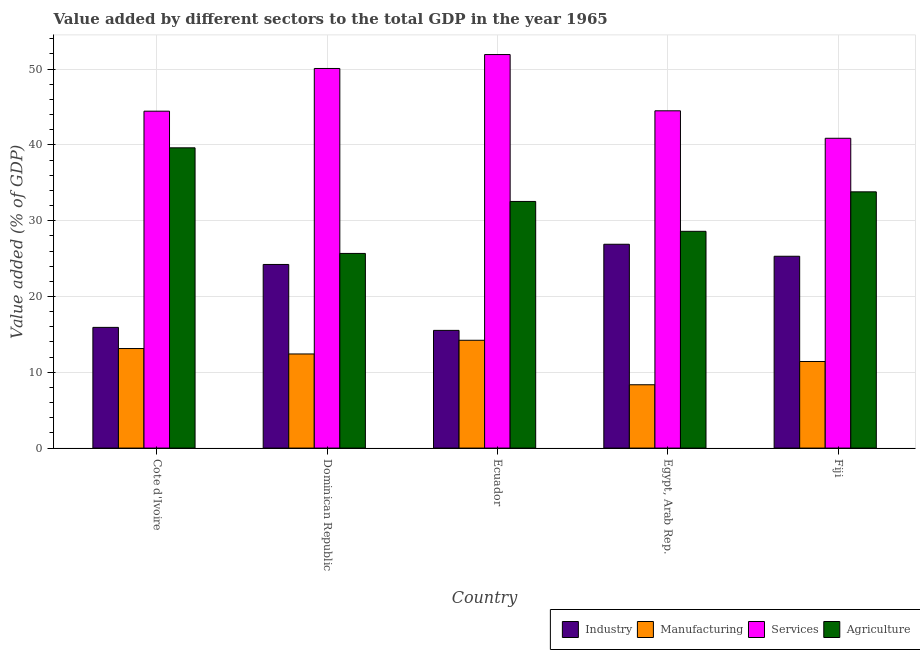How many different coloured bars are there?
Offer a terse response. 4. How many groups of bars are there?
Provide a succinct answer. 5. What is the label of the 4th group of bars from the left?
Your answer should be compact. Egypt, Arab Rep. What is the value added by industrial sector in Egypt, Arab Rep.?
Provide a succinct answer. 26.9. Across all countries, what is the maximum value added by manufacturing sector?
Offer a very short reply. 14.23. Across all countries, what is the minimum value added by agricultural sector?
Offer a terse response. 25.68. In which country was the value added by industrial sector maximum?
Offer a terse response. Egypt, Arab Rep. In which country was the value added by agricultural sector minimum?
Keep it short and to the point. Dominican Republic. What is the total value added by services sector in the graph?
Offer a very short reply. 231.85. What is the difference between the value added by services sector in Ecuador and that in Egypt, Arab Rep.?
Give a very brief answer. 7.42. What is the difference between the value added by industrial sector in Dominican Republic and the value added by agricultural sector in Egypt, Arab Rep.?
Offer a very short reply. -4.37. What is the average value added by manufacturing sector per country?
Keep it short and to the point. 11.91. What is the difference between the value added by manufacturing sector and value added by industrial sector in Egypt, Arab Rep.?
Make the answer very short. -18.54. In how many countries, is the value added by agricultural sector greater than 26 %?
Keep it short and to the point. 4. What is the ratio of the value added by industrial sector in Ecuador to that in Egypt, Arab Rep.?
Provide a succinct answer. 0.58. What is the difference between the highest and the second highest value added by industrial sector?
Provide a short and direct response. 1.58. What is the difference between the highest and the lowest value added by manufacturing sector?
Offer a terse response. 5.87. Is the sum of the value added by industrial sector in Egypt, Arab Rep. and Fiji greater than the maximum value added by agricultural sector across all countries?
Your response must be concise. Yes. What does the 4th bar from the left in Cote d'Ivoire represents?
Your answer should be compact. Agriculture. What does the 1st bar from the right in Cote d'Ivoire represents?
Offer a terse response. Agriculture. Is it the case that in every country, the sum of the value added by industrial sector and value added by manufacturing sector is greater than the value added by services sector?
Ensure brevity in your answer.  No. Are all the bars in the graph horizontal?
Your response must be concise. No. How many countries are there in the graph?
Keep it short and to the point. 5. Are the values on the major ticks of Y-axis written in scientific E-notation?
Make the answer very short. No. Does the graph contain any zero values?
Your answer should be compact. No. Where does the legend appear in the graph?
Your response must be concise. Bottom right. What is the title of the graph?
Your answer should be very brief. Value added by different sectors to the total GDP in the year 1965. What is the label or title of the X-axis?
Ensure brevity in your answer.  Country. What is the label or title of the Y-axis?
Offer a very short reply. Value added (% of GDP). What is the Value added (% of GDP) of Industry in Cote d'Ivoire?
Offer a very short reply. 15.93. What is the Value added (% of GDP) in Manufacturing in Cote d'Ivoire?
Offer a very short reply. 13.13. What is the Value added (% of GDP) in Services in Cote d'Ivoire?
Give a very brief answer. 44.45. What is the Value added (% of GDP) in Agriculture in Cote d'Ivoire?
Your answer should be compact. 39.62. What is the Value added (% of GDP) of Industry in Dominican Republic?
Offer a terse response. 24.23. What is the Value added (% of GDP) of Manufacturing in Dominican Republic?
Your response must be concise. 12.42. What is the Value added (% of GDP) in Services in Dominican Republic?
Offer a very short reply. 50.09. What is the Value added (% of GDP) of Agriculture in Dominican Republic?
Offer a very short reply. 25.68. What is the Value added (% of GDP) in Industry in Ecuador?
Give a very brief answer. 15.53. What is the Value added (% of GDP) in Manufacturing in Ecuador?
Give a very brief answer. 14.23. What is the Value added (% of GDP) in Services in Ecuador?
Offer a very short reply. 51.93. What is the Value added (% of GDP) of Agriculture in Ecuador?
Give a very brief answer. 32.54. What is the Value added (% of GDP) of Industry in Egypt, Arab Rep.?
Your response must be concise. 26.9. What is the Value added (% of GDP) of Manufacturing in Egypt, Arab Rep.?
Give a very brief answer. 8.36. What is the Value added (% of GDP) in Services in Egypt, Arab Rep.?
Ensure brevity in your answer.  44.5. What is the Value added (% of GDP) of Agriculture in Egypt, Arab Rep.?
Offer a very short reply. 28.6. What is the Value added (% of GDP) of Industry in Fiji?
Provide a succinct answer. 25.31. What is the Value added (% of GDP) in Manufacturing in Fiji?
Your answer should be very brief. 11.43. What is the Value added (% of GDP) of Services in Fiji?
Ensure brevity in your answer.  40.88. What is the Value added (% of GDP) of Agriculture in Fiji?
Your response must be concise. 33.81. Across all countries, what is the maximum Value added (% of GDP) of Industry?
Make the answer very short. 26.9. Across all countries, what is the maximum Value added (% of GDP) in Manufacturing?
Ensure brevity in your answer.  14.23. Across all countries, what is the maximum Value added (% of GDP) in Services?
Offer a terse response. 51.93. Across all countries, what is the maximum Value added (% of GDP) of Agriculture?
Your response must be concise. 39.62. Across all countries, what is the minimum Value added (% of GDP) in Industry?
Offer a terse response. 15.53. Across all countries, what is the minimum Value added (% of GDP) in Manufacturing?
Provide a short and direct response. 8.36. Across all countries, what is the minimum Value added (% of GDP) of Services?
Keep it short and to the point. 40.88. Across all countries, what is the minimum Value added (% of GDP) in Agriculture?
Keep it short and to the point. 25.68. What is the total Value added (% of GDP) in Industry in the graph?
Provide a succinct answer. 107.89. What is the total Value added (% of GDP) of Manufacturing in the graph?
Make the answer very short. 59.56. What is the total Value added (% of GDP) of Services in the graph?
Your answer should be compact. 231.85. What is the total Value added (% of GDP) of Agriculture in the graph?
Keep it short and to the point. 160.26. What is the difference between the Value added (% of GDP) in Industry in Cote d'Ivoire and that in Dominican Republic?
Offer a very short reply. -8.3. What is the difference between the Value added (% of GDP) of Manufacturing in Cote d'Ivoire and that in Dominican Republic?
Ensure brevity in your answer.  0.72. What is the difference between the Value added (% of GDP) in Services in Cote d'Ivoire and that in Dominican Republic?
Give a very brief answer. -5.63. What is the difference between the Value added (% of GDP) of Agriculture in Cote d'Ivoire and that in Dominican Republic?
Your answer should be compact. 13.93. What is the difference between the Value added (% of GDP) in Industry in Cote d'Ivoire and that in Ecuador?
Keep it short and to the point. 0.4. What is the difference between the Value added (% of GDP) of Manufacturing in Cote d'Ivoire and that in Ecuador?
Ensure brevity in your answer.  -1.09. What is the difference between the Value added (% of GDP) of Services in Cote d'Ivoire and that in Ecuador?
Your response must be concise. -7.47. What is the difference between the Value added (% of GDP) in Agriculture in Cote d'Ivoire and that in Ecuador?
Provide a succinct answer. 7.08. What is the difference between the Value added (% of GDP) of Industry in Cote d'Ivoire and that in Egypt, Arab Rep.?
Keep it short and to the point. -10.97. What is the difference between the Value added (% of GDP) of Manufacturing in Cote d'Ivoire and that in Egypt, Arab Rep.?
Provide a short and direct response. 4.78. What is the difference between the Value added (% of GDP) of Services in Cote d'Ivoire and that in Egypt, Arab Rep.?
Give a very brief answer. -0.05. What is the difference between the Value added (% of GDP) in Agriculture in Cote d'Ivoire and that in Egypt, Arab Rep.?
Provide a succinct answer. 11.02. What is the difference between the Value added (% of GDP) in Industry in Cote d'Ivoire and that in Fiji?
Keep it short and to the point. -9.38. What is the difference between the Value added (% of GDP) in Manufacturing in Cote d'Ivoire and that in Fiji?
Offer a terse response. 1.71. What is the difference between the Value added (% of GDP) of Services in Cote d'Ivoire and that in Fiji?
Offer a very short reply. 3.58. What is the difference between the Value added (% of GDP) in Agriculture in Cote d'Ivoire and that in Fiji?
Your response must be concise. 5.81. What is the difference between the Value added (% of GDP) of Industry in Dominican Republic and that in Ecuador?
Ensure brevity in your answer.  8.7. What is the difference between the Value added (% of GDP) in Manufacturing in Dominican Republic and that in Ecuador?
Make the answer very short. -1.81. What is the difference between the Value added (% of GDP) of Services in Dominican Republic and that in Ecuador?
Keep it short and to the point. -1.84. What is the difference between the Value added (% of GDP) in Agriculture in Dominican Republic and that in Ecuador?
Keep it short and to the point. -6.86. What is the difference between the Value added (% of GDP) of Industry in Dominican Republic and that in Egypt, Arab Rep.?
Your response must be concise. -2.67. What is the difference between the Value added (% of GDP) of Manufacturing in Dominican Republic and that in Egypt, Arab Rep.?
Provide a succinct answer. 4.06. What is the difference between the Value added (% of GDP) of Services in Dominican Republic and that in Egypt, Arab Rep.?
Make the answer very short. 5.58. What is the difference between the Value added (% of GDP) of Agriculture in Dominican Republic and that in Egypt, Arab Rep.?
Keep it short and to the point. -2.92. What is the difference between the Value added (% of GDP) of Industry in Dominican Republic and that in Fiji?
Offer a very short reply. -1.08. What is the difference between the Value added (% of GDP) in Services in Dominican Republic and that in Fiji?
Provide a succinct answer. 9.21. What is the difference between the Value added (% of GDP) of Agriculture in Dominican Republic and that in Fiji?
Offer a very short reply. -8.13. What is the difference between the Value added (% of GDP) of Industry in Ecuador and that in Egypt, Arab Rep.?
Provide a short and direct response. -11.36. What is the difference between the Value added (% of GDP) in Manufacturing in Ecuador and that in Egypt, Arab Rep.?
Provide a short and direct response. 5.87. What is the difference between the Value added (% of GDP) of Services in Ecuador and that in Egypt, Arab Rep.?
Provide a succinct answer. 7.42. What is the difference between the Value added (% of GDP) in Agriculture in Ecuador and that in Egypt, Arab Rep.?
Your answer should be compact. 3.94. What is the difference between the Value added (% of GDP) in Industry in Ecuador and that in Fiji?
Keep it short and to the point. -9.78. What is the difference between the Value added (% of GDP) in Manufacturing in Ecuador and that in Fiji?
Offer a terse response. 2.8. What is the difference between the Value added (% of GDP) of Services in Ecuador and that in Fiji?
Your answer should be compact. 11.05. What is the difference between the Value added (% of GDP) in Agriculture in Ecuador and that in Fiji?
Offer a very short reply. -1.27. What is the difference between the Value added (% of GDP) in Industry in Egypt, Arab Rep. and that in Fiji?
Your answer should be compact. 1.58. What is the difference between the Value added (% of GDP) of Manufacturing in Egypt, Arab Rep. and that in Fiji?
Provide a short and direct response. -3.07. What is the difference between the Value added (% of GDP) in Services in Egypt, Arab Rep. and that in Fiji?
Your answer should be compact. 3.62. What is the difference between the Value added (% of GDP) of Agriculture in Egypt, Arab Rep. and that in Fiji?
Ensure brevity in your answer.  -5.21. What is the difference between the Value added (% of GDP) in Industry in Cote d'Ivoire and the Value added (% of GDP) in Manufacturing in Dominican Republic?
Give a very brief answer. 3.51. What is the difference between the Value added (% of GDP) of Industry in Cote d'Ivoire and the Value added (% of GDP) of Services in Dominican Republic?
Offer a terse response. -34.16. What is the difference between the Value added (% of GDP) of Industry in Cote d'Ivoire and the Value added (% of GDP) of Agriculture in Dominican Republic?
Give a very brief answer. -9.76. What is the difference between the Value added (% of GDP) of Manufacturing in Cote d'Ivoire and the Value added (% of GDP) of Services in Dominican Republic?
Give a very brief answer. -36.95. What is the difference between the Value added (% of GDP) in Manufacturing in Cote d'Ivoire and the Value added (% of GDP) in Agriculture in Dominican Republic?
Offer a very short reply. -12.55. What is the difference between the Value added (% of GDP) in Services in Cote d'Ivoire and the Value added (% of GDP) in Agriculture in Dominican Republic?
Your response must be concise. 18.77. What is the difference between the Value added (% of GDP) in Industry in Cote d'Ivoire and the Value added (% of GDP) in Manufacturing in Ecuador?
Provide a succinct answer. 1.7. What is the difference between the Value added (% of GDP) of Industry in Cote d'Ivoire and the Value added (% of GDP) of Services in Ecuador?
Give a very brief answer. -36. What is the difference between the Value added (% of GDP) of Industry in Cote d'Ivoire and the Value added (% of GDP) of Agriculture in Ecuador?
Offer a terse response. -16.62. What is the difference between the Value added (% of GDP) in Manufacturing in Cote d'Ivoire and the Value added (% of GDP) in Services in Ecuador?
Your answer should be compact. -38.79. What is the difference between the Value added (% of GDP) in Manufacturing in Cote d'Ivoire and the Value added (% of GDP) in Agriculture in Ecuador?
Provide a succinct answer. -19.41. What is the difference between the Value added (% of GDP) of Services in Cote d'Ivoire and the Value added (% of GDP) of Agriculture in Ecuador?
Provide a succinct answer. 11.91. What is the difference between the Value added (% of GDP) of Industry in Cote d'Ivoire and the Value added (% of GDP) of Manufacturing in Egypt, Arab Rep.?
Offer a very short reply. 7.57. What is the difference between the Value added (% of GDP) in Industry in Cote d'Ivoire and the Value added (% of GDP) in Services in Egypt, Arab Rep.?
Give a very brief answer. -28.58. What is the difference between the Value added (% of GDP) in Industry in Cote d'Ivoire and the Value added (% of GDP) in Agriculture in Egypt, Arab Rep.?
Keep it short and to the point. -12.67. What is the difference between the Value added (% of GDP) of Manufacturing in Cote d'Ivoire and the Value added (% of GDP) of Services in Egypt, Arab Rep.?
Ensure brevity in your answer.  -31.37. What is the difference between the Value added (% of GDP) in Manufacturing in Cote d'Ivoire and the Value added (% of GDP) in Agriculture in Egypt, Arab Rep.?
Offer a terse response. -15.47. What is the difference between the Value added (% of GDP) in Services in Cote d'Ivoire and the Value added (% of GDP) in Agriculture in Egypt, Arab Rep.?
Ensure brevity in your answer.  15.85. What is the difference between the Value added (% of GDP) of Industry in Cote d'Ivoire and the Value added (% of GDP) of Manufacturing in Fiji?
Provide a short and direct response. 4.5. What is the difference between the Value added (% of GDP) in Industry in Cote d'Ivoire and the Value added (% of GDP) in Services in Fiji?
Offer a terse response. -24.95. What is the difference between the Value added (% of GDP) in Industry in Cote d'Ivoire and the Value added (% of GDP) in Agriculture in Fiji?
Give a very brief answer. -17.88. What is the difference between the Value added (% of GDP) in Manufacturing in Cote d'Ivoire and the Value added (% of GDP) in Services in Fiji?
Your answer should be very brief. -27.74. What is the difference between the Value added (% of GDP) of Manufacturing in Cote d'Ivoire and the Value added (% of GDP) of Agriculture in Fiji?
Make the answer very short. -20.68. What is the difference between the Value added (% of GDP) of Services in Cote d'Ivoire and the Value added (% of GDP) of Agriculture in Fiji?
Provide a short and direct response. 10.64. What is the difference between the Value added (% of GDP) in Industry in Dominican Republic and the Value added (% of GDP) in Manufacturing in Ecuador?
Offer a very short reply. 10. What is the difference between the Value added (% of GDP) of Industry in Dominican Republic and the Value added (% of GDP) of Services in Ecuador?
Keep it short and to the point. -27.7. What is the difference between the Value added (% of GDP) in Industry in Dominican Republic and the Value added (% of GDP) in Agriculture in Ecuador?
Provide a succinct answer. -8.31. What is the difference between the Value added (% of GDP) in Manufacturing in Dominican Republic and the Value added (% of GDP) in Services in Ecuador?
Provide a short and direct response. -39.51. What is the difference between the Value added (% of GDP) in Manufacturing in Dominican Republic and the Value added (% of GDP) in Agriculture in Ecuador?
Make the answer very short. -20.12. What is the difference between the Value added (% of GDP) of Services in Dominican Republic and the Value added (% of GDP) of Agriculture in Ecuador?
Your answer should be compact. 17.54. What is the difference between the Value added (% of GDP) of Industry in Dominican Republic and the Value added (% of GDP) of Manufacturing in Egypt, Arab Rep.?
Your answer should be very brief. 15.87. What is the difference between the Value added (% of GDP) in Industry in Dominican Republic and the Value added (% of GDP) in Services in Egypt, Arab Rep.?
Your answer should be very brief. -20.28. What is the difference between the Value added (% of GDP) of Industry in Dominican Republic and the Value added (% of GDP) of Agriculture in Egypt, Arab Rep.?
Keep it short and to the point. -4.37. What is the difference between the Value added (% of GDP) in Manufacturing in Dominican Republic and the Value added (% of GDP) in Services in Egypt, Arab Rep.?
Your response must be concise. -32.08. What is the difference between the Value added (% of GDP) of Manufacturing in Dominican Republic and the Value added (% of GDP) of Agriculture in Egypt, Arab Rep.?
Ensure brevity in your answer.  -16.18. What is the difference between the Value added (% of GDP) of Services in Dominican Republic and the Value added (% of GDP) of Agriculture in Egypt, Arab Rep.?
Your answer should be very brief. 21.49. What is the difference between the Value added (% of GDP) of Industry in Dominican Republic and the Value added (% of GDP) of Manufacturing in Fiji?
Keep it short and to the point. 12.8. What is the difference between the Value added (% of GDP) of Industry in Dominican Republic and the Value added (% of GDP) of Services in Fiji?
Offer a terse response. -16.65. What is the difference between the Value added (% of GDP) of Industry in Dominican Republic and the Value added (% of GDP) of Agriculture in Fiji?
Offer a very short reply. -9.58. What is the difference between the Value added (% of GDP) in Manufacturing in Dominican Republic and the Value added (% of GDP) in Services in Fiji?
Ensure brevity in your answer.  -28.46. What is the difference between the Value added (% of GDP) in Manufacturing in Dominican Republic and the Value added (% of GDP) in Agriculture in Fiji?
Your answer should be very brief. -21.39. What is the difference between the Value added (% of GDP) in Services in Dominican Republic and the Value added (% of GDP) in Agriculture in Fiji?
Offer a terse response. 16.28. What is the difference between the Value added (% of GDP) of Industry in Ecuador and the Value added (% of GDP) of Manufacturing in Egypt, Arab Rep.?
Give a very brief answer. 7.17. What is the difference between the Value added (% of GDP) of Industry in Ecuador and the Value added (% of GDP) of Services in Egypt, Arab Rep.?
Offer a terse response. -28.97. What is the difference between the Value added (% of GDP) of Industry in Ecuador and the Value added (% of GDP) of Agriculture in Egypt, Arab Rep.?
Offer a very short reply. -13.07. What is the difference between the Value added (% of GDP) of Manufacturing in Ecuador and the Value added (% of GDP) of Services in Egypt, Arab Rep.?
Make the answer very short. -30.28. What is the difference between the Value added (% of GDP) of Manufacturing in Ecuador and the Value added (% of GDP) of Agriculture in Egypt, Arab Rep.?
Give a very brief answer. -14.38. What is the difference between the Value added (% of GDP) of Services in Ecuador and the Value added (% of GDP) of Agriculture in Egypt, Arab Rep.?
Make the answer very short. 23.32. What is the difference between the Value added (% of GDP) of Industry in Ecuador and the Value added (% of GDP) of Manufacturing in Fiji?
Give a very brief answer. 4.11. What is the difference between the Value added (% of GDP) in Industry in Ecuador and the Value added (% of GDP) in Services in Fiji?
Give a very brief answer. -25.35. What is the difference between the Value added (% of GDP) of Industry in Ecuador and the Value added (% of GDP) of Agriculture in Fiji?
Make the answer very short. -18.28. What is the difference between the Value added (% of GDP) in Manufacturing in Ecuador and the Value added (% of GDP) in Services in Fiji?
Your answer should be compact. -26.65. What is the difference between the Value added (% of GDP) of Manufacturing in Ecuador and the Value added (% of GDP) of Agriculture in Fiji?
Provide a succinct answer. -19.59. What is the difference between the Value added (% of GDP) in Services in Ecuador and the Value added (% of GDP) in Agriculture in Fiji?
Your answer should be compact. 18.11. What is the difference between the Value added (% of GDP) of Industry in Egypt, Arab Rep. and the Value added (% of GDP) of Manufacturing in Fiji?
Offer a terse response. 15.47. What is the difference between the Value added (% of GDP) of Industry in Egypt, Arab Rep. and the Value added (% of GDP) of Services in Fiji?
Offer a very short reply. -13.98. What is the difference between the Value added (% of GDP) of Industry in Egypt, Arab Rep. and the Value added (% of GDP) of Agriculture in Fiji?
Ensure brevity in your answer.  -6.92. What is the difference between the Value added (% of GDP) in Manufacturing in Egypt, Arab Rep. and the Value added (% of GDP) in Services in Fiji?
Offer a terse response. -32.52. What is the difference between the Value added (% of GDP) in Manufacturing in Egypt, Arab Rep. and the Value added (% of GDP) in Agriculture in Fiji?
Offer a terse response. -25.45. What is the difference between the Value added (% of GDP) in Services in Egypt, Arab Rep. and the Value added (% of GDP) in Agriculture in Fiji?
Your response must be concise. 10.69. What is the average Value added (% of GDP) in Industry per country?
Provide a short and direct response. 21.58. What is the average Value added (% of GDP) of Manufacturing per country?
Your response must be concise. 11.91. What is the average Value added (% of GDP) in Services per country?
Your answer should be very brief. 46.37. What is the average Value added (% of GDP) of Agriculture per country?
Make the answer very short. 32.05. What is the difference between the Value added (% of GDP) in Industry and Value added (% of GDP) in Manufacturing in Cote d'Ivoire?
Offer a terse response. 2.79. What is the difference between the Value added (% of GDP) in Industry and Value added (% of GDP) in Services in Cote d'Ivoire?
Your answer should be compact. -28.53. What is the difference between the Value added (% of GDP) in Industry and Value added (% of GDP) in Agriculture in Cote d'Ivoire?
Your response must be concise. -23.69. What is the difference between the Value added (% of GDP) in Manufacturing and Value added (% of GDP) in Services in Cote d'Ivoire?
Keep it short and to the point. -31.32. What is the difference between the Value added (% of GDP) in Manufacturing and Value added (% of GDP) in Agriculture in Cote d'Ivoire?
Your answer should be very brief. -26.48. What is the difference between the Value added (% of GDP) in Services and Value added (% of GDP) in Agriculture in Cote d'Ivoire?
Offer a very short reply. 4.84. What is the difference between the Value added (% of GDP) of Industry and Value added (% of GDP) of Manufacturing in Dominican Republic?
Offer a terse response. 11.81. What is the difference between the Value added (% of GDP) in Industry and Value added (% of GDP) in Services in Dominican Republic?
Your answer should be very brief. -25.86. What is the difference between the Value added (% of GDP) of Industry and Value added (% of GDP) of Agriculture in Dominican Republic?
Make the answer very short. -1.46. What is the difference between the Value added (% of GDP) in Manufacturing and Value added (% of GDP) in Services in Dominican Republic?
Give a very brief answer. -37.67. What is the difference between the Value added (% of GDP) of Manufacturing and Value added (% of GDP) of Agriculture in Dominican Republic?
Give a very brief answer. -13.27. What is the difference between the Value added (% of GDP) of Services and Value added (% of GDP) of Agriculture in Dominican Republic?
Your answer should be very brief. 24.4. What is the difference between the Value added (% of GDP) in Industry and Value added (% of GDP) in Manufacturing in Ecuador?
Make the answer very short. 1.31. What is the difference between the Value added (% of GDP) in Industry and Value added (% of GDP) in Services in Ecuador?
Your response must be concise. -36.39. What is the difference between the Value added (% of GDP) in Industry and Value added (% of GDP) in Agriculture in Ecuador?
Give a very brief answer. -17.01. What is the difference between the Value added (% of GDP) in Manufacturing and Value added (% of GDP) in Services in Ecuador?
Ensure brevity in your answer.  -37.7. What is the difference between the Value added (% of GDP) in Manufacturing and Value added (% of GDP) in Agriculture in Ecuador?
Keep it short and to the point. -18.32. What is the difference between the Value added (% of GDP) in Services and Value added (% of GDP) in Agriculture in Ecuador?
Give a very brief answer. 19.38. What is the difference between the Value added (% of GDP) in Industry and Value added (% of GDP) in Manufacturing in Egypt, Arab Rep.?
Provide a succinct answer. 18.54. What is the difference between the Value added (% of GDP) of Industry and Value added (% of GDP) of Services in Egypt, Arab Rep.?
Provide a succinct answer. -17.61. What is the difference between the Value added (% of GDP) in Industry and Value added (% of GDP) in Agriculture in Egypt, Arab Rep.?
Ensure brevity in your answer.  -1.71. What is the difference between the Value added (% of GDP) in Manufacturing and Value added (% of GDP) in Services in Egypt, Arab Rep.?
Your answer should be compact. -36.15. What is the difference between the Value added (% of GDP) in Manufacturing and Value added (% of GDP) in Agriculture in Egypt, Arab Rep.?
Provide a short and direct response. -20.24. What is the difference between the Value added (% of GDP) of Services and Value added (% of GDP) of Agriculture in Egypt, Arab Rep.?
Make the answer very short. 15.9. What is the difference between the Value added (% of GDP) of Industry and Value added (% of GDP) of Manufacturing in Fiji?
Make the answer very short. 13.88. What is the difference between the Value added (% of GDP) in Industry and Value added (% of GDP) in Services in Fiji?
Provide a short and direct response. -15.57. What is the difference between the Value added (% of GDP) in Industry and Value added (% of GDP) in Agriculture in Fiji?
Keep it short and to the point. -8.5. What is the difference between the Value added (% of GDP) in Manufacturing and Value added (% of GDP) in Services in Fiji?
Give a very brief answer. -29.45. What is the difference between the Value added (% of GDP) of Manufacturing and Value added (% of GDP) of Agriculture in Fiji?
Provide a short and direct response. -22.38. What is the difference between the Value added (% of GDP) of Services and Value added (% of GDP) of Agriculture in Fiji?
Your response must be concise. 7.07. What is the ratio of the Value added (% of GDP) of Industry in Cote d'Ivoire to that in Dominican Republic?
Provide a short and direct response. 0.66. What is the ratio of the Value added (% of GDP) in Manufacturing in Cote d'Ivoire to that in Dominican Republic?
Provide a succinct answer. 1.06. What is the ratio of the Value added (% of GDP) in Services in Cote d'Ivoire to that in Dominican Republic?
Ensure brevity in your answer.  0.89. What is the ratio of the Value added (% of GDP) of Agriculture in Cote d'Ivoire to that in Dominican Republic?
Offer a very short reply. 1.54. What is the ratio of the Value added (% of GDP) in Industry in Cote d'Ivoire to that in Ecuador?
Ensure brevity in your answer.  1.03. What is the ratio of the Value added (% of GDP) in Manufacturing in Cote d'Ivoire to that in Ecuador?
Offer a very short reply. 0.92. What is the ratio of the Value added (% of GDP) in Services in Cote d'Ivoire to that in Ecuador?
Your answer should be compact. 0.86. What is the ratio of the Value added (% of GDP) in Agriculture in Cote d'Ivoire to that in Ecuador?
Give a very brief answer. 1.22. What is the ratio of the Value added (% of GDP) of Industry in Cote d'Ivoire to that in Egypt, Arab Rep.?
Provide a succinct answer. 0.59. What is the ratio of the Value added (% of GDP) of Manufacturing in Cote d'Ivoire to that in Egypt, Arab Rep.?
Make the answer very short. 1.57. What is the ratio of the Value added (% of GDP) of Services in Cote d'Ivoire to that in Egypt, Arab Rep.?
Provide a short and direct response. 1. What is the ratio of the Value added (% of GDP) in Agriculture in Cote d'Ivoire to that in Egypt, Arab Rep.?
Your answer should be compact. 1.39. What is the ratio of the Value added (% of GDP) in Industry in Cote d'Ivoire to that in Fiji?
Provide a short and direct response. 0.63. What is the ratio of the Value added (% of GDP) in Manufacturing in Cote d'Ivoire to that in Fiji?
Keep it short and to the point. 1.15. What is the ratio of the Value added (% of GDP) in Services in Cote d'Ivoire to that in Fiji?
Your answer should be very brief. 1.09. What is the ratio of the Value added (% of GDP) in Agriculture in Cote d'Ivoire to that in Fiji?
Ensure brevity in your answer.  1.17. What is the ratio of the Value added (% of GDP) of Industry in Dominican Republic to that in Ecuador?
Give a very brief answer. 1.56. What is the ratio of the Value added (% of GDP) in Manufacturing in Dominican Republic to that in Ecuador?
Your answer should be compact. 0.87. What is the ratio of the Value added (% of GDP) in Services in Dominican Republic to that in Ecuador?
Your answer should be compact. 0.96. What is the ratio of the Value added (% of GDP) in Agriculture in Dominican Republic to that in Ecuador?
Ensure brevity in your answer.  0.79. What is the ratio of the Value added (% of GDP) in Industry in Dominican Republic to that in Egypt, Arab Rep.?
Ensure brevity in your answer.  0.9. What is the ratio of the Value added (% of GDP) in Manufacturing in Dominican Republic to that in Egypt, Arab Rep.?
Provide a succinct answer. 1.49. What is the ratio of the Value added (% of GDP) in Services in Dominican Republic to that in Egypt, Arab Rep.?
Offer a terse response. 1.13. What is the ratio of the Value added (% of GDP) of Agriculture in Dominican Republic to that in Egypt, Arab Rep.?
Provide a succinct answer. 0.9. What is the ratio of the Value added (% of GDP) of Industry in Dominican Republic to that in Fiji?
Offer a terse response. 0.96. What is the ratio of the Value added (% of GDP) of Manufacturing in Dominican Republic to that in Fiji?
Offer a very short reply. 1.09. What is the ratio of the Value added (% of GDP) in Services in Dominican Republic to that in Fiji?
Give a very brief answer. 1.23. What is the ratio of the Value added (% of GDP) of Agriculture in Dominican Republic to that in Fiji?
Your answer should be very brief. 0.76. What is the ratio of the Value added (% of GDP) in Industry in Ecuador to that in Egypt, Arab Rep.?
Ensure brevity in your answer.  0.58. What is the ratio of the Value added (% of GDP) of Manufacturing in Ecuador to that in Egypt, Arab Rep.?
Your answer should be compact. 1.7. What is the ratio of the Value added (% of GDP) of Services in Ecuador to that in Egypt, Arab Rep.?
Make the answer very short. 1.17. What is the ratio of the Value added (% of GDP) of Agriculture in Ecuador to that in Egypt, Arab Rep.?
Your answer should be compact. 1.14. What is the ratio of the Value added (% of GDP) in Industry in Ecuador to that in Fiji?
Your response must be concise. 0.61. What is the ratio of the Value added (% of GDP) in Manufacturing in Ecuador to that in Fiji?
Your answer should be compact. 1.24. What is the ratio of the Value added (% of GDP) in Services in Ecuador to that in Fiji?
Provide a short and direct response. 1.27. What is the ratio of the Value added (% of GDP) in Agriculture in Ecuador to that in Fiji?
Make the answer very short. 0.96. What is the ratio of the Value added (% of GDP) in Industry in Egypt, Arab Rep. to that in Fiji?
Offer a very short reply. 1.06. What is the ratio of the Value added (% of GDP) of Manufacturing in Egypt, Arab Rep. to that in Fiji?
Provide a short and direct response. 0.73. What is the ratio of the Value added (% of GDP) of Services in Egypt, Arab Rep. to that in Fiji?
Make the answer very short. 1.09. What is the ratio of the Value added (% of GDP) in Agriculture in Egypt, Arab Rep. to that in Fiji?
Your answer should be compact. 0.85. What is the difference between the highest and the second highest Value added (% of GDP) in Industry?
Give a very brief answer. 1.58. What is the difference between the highest and the second highest Value added (% of GDP) of Manufacturing?
Your answer should be compact. 1.09. What is the difference between the highest and the second highest Value added (% of GDP) in Services?
Your answer should be very brief. 1.84. What is the difference between the highest and the second highest Value added (% of GDP) in Agriculture?
Ensure brevity in your answer.  5.81. What is the difference between the highest and the lowest Value added (% of GDP) of Industry?
Offer a terse response. 11.36. What is the difference between the highest and the lowest Value added (% of GDP) of Manufacturing?
Keep it short and to the point. 5.87. What is the difference between the highest and the lowest Value added (% of GDP) of Services?
Give a very brief answer. 11.05. What is the difference between the highest and the lowest Value added (% of GDP) in Agriculture?
Provide a short and direct response. 13.93. 